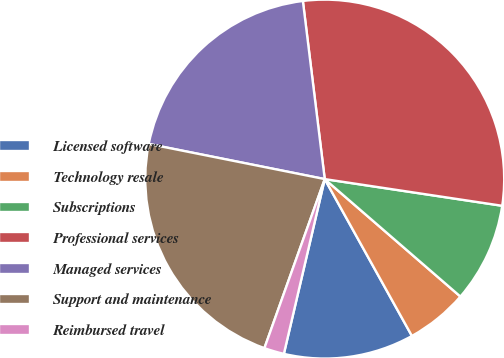Convert chart. <chart><loc_0><loc_0><loc_500><loc_500><pie_chart><fcel>Licensed software<fcel>Technology resale<fcel>Subscriptions<fcel>Professional services<fcel>Managed services<fcel>Support and maintenance<fcel>Reimbursed travel<nl><fcel>11.73%<fcel>5.57%<fcel>8.98%<fcel>29.32%<fcel>19.92%<fcel>22.68%<fcel>1.8%<nl></chart> 